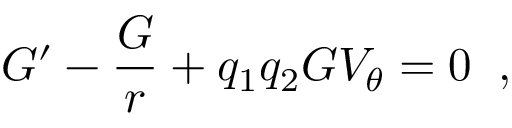Convert formula to latex. <formula><loc_0><loc_0><loc_500><loc_500>G ^ { \prime } - \frac { G } { r } + q _ { 1 } q _ { 2 } G V _ { \theta } = 0 \, ,</formula> 